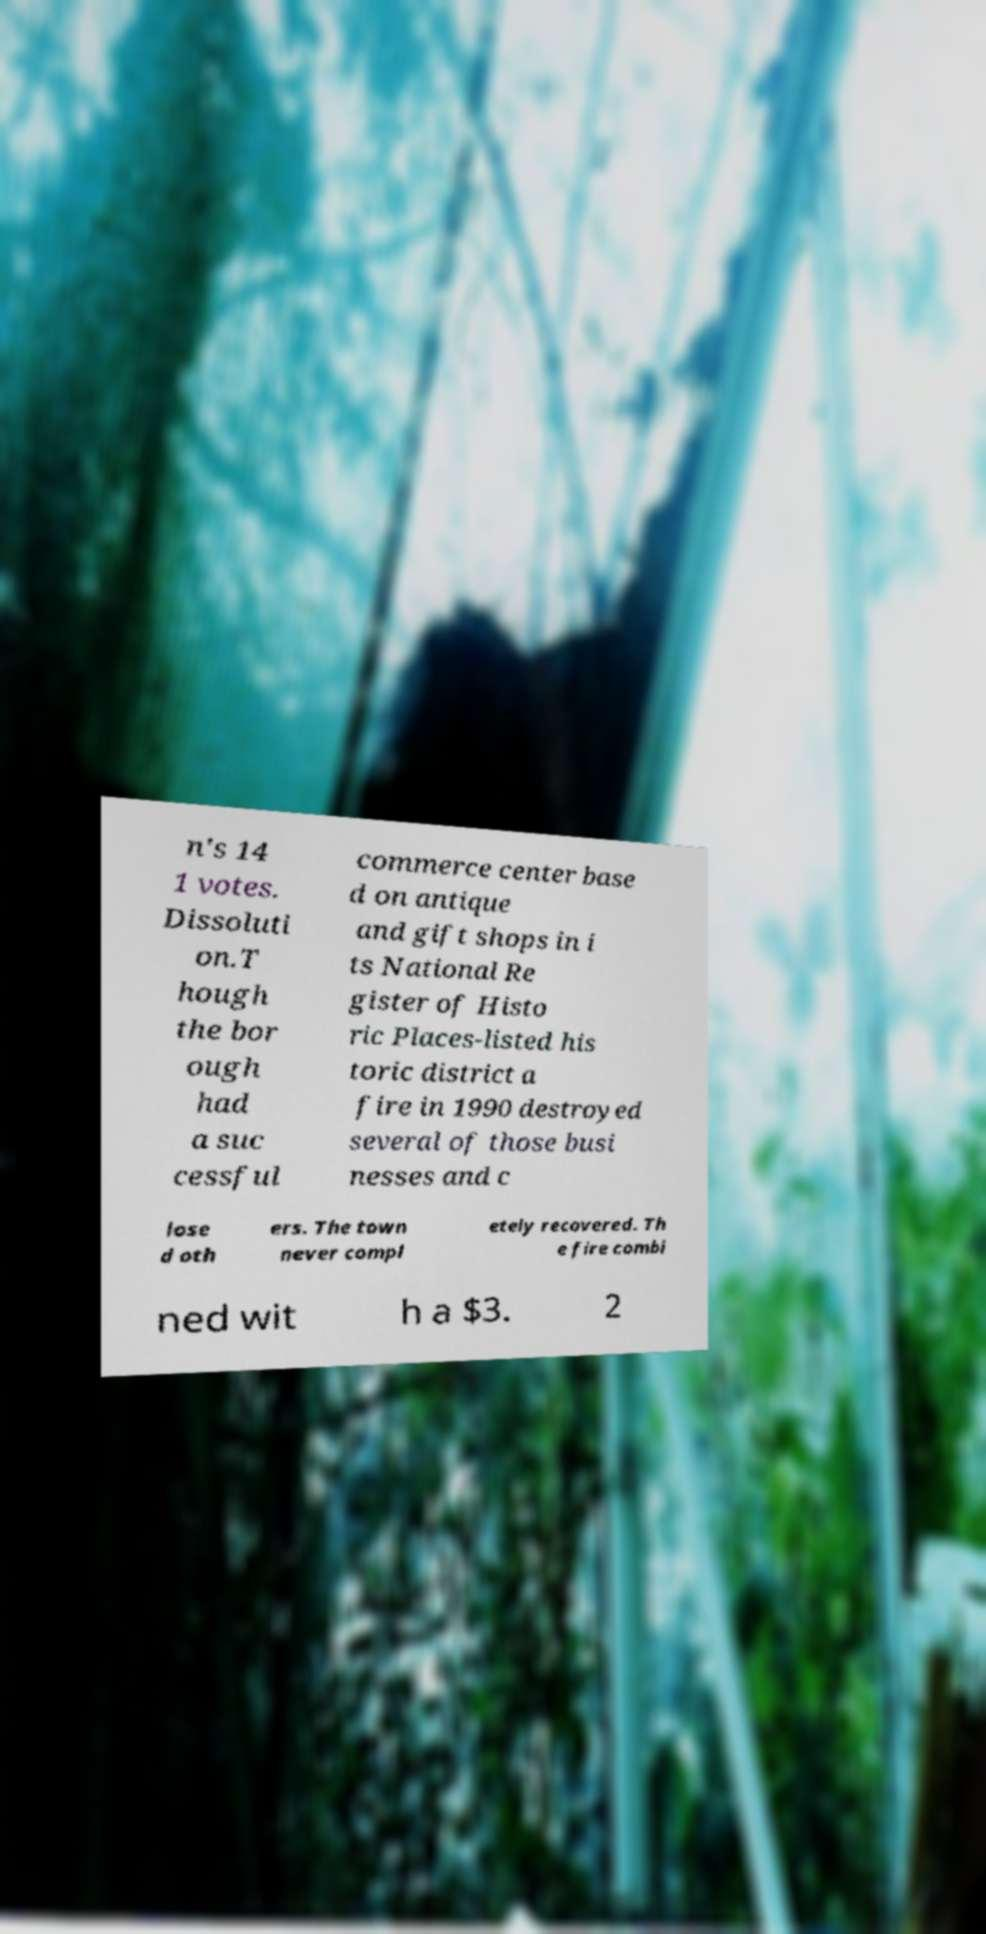Please identify and transcribe the text found in this image. n's 14 1 votes. Dissoluti on.T hough the bor ough had a suc cessful commerce center base d on antique and gift shops in i ts National Re gister of Histo ric Places-listed his toric district a fire in 1990 destroyed several of those busi nesses and c lose d oth ers. The town never compl etely recovered. Th e fire combi ned wit h a $3. 2 